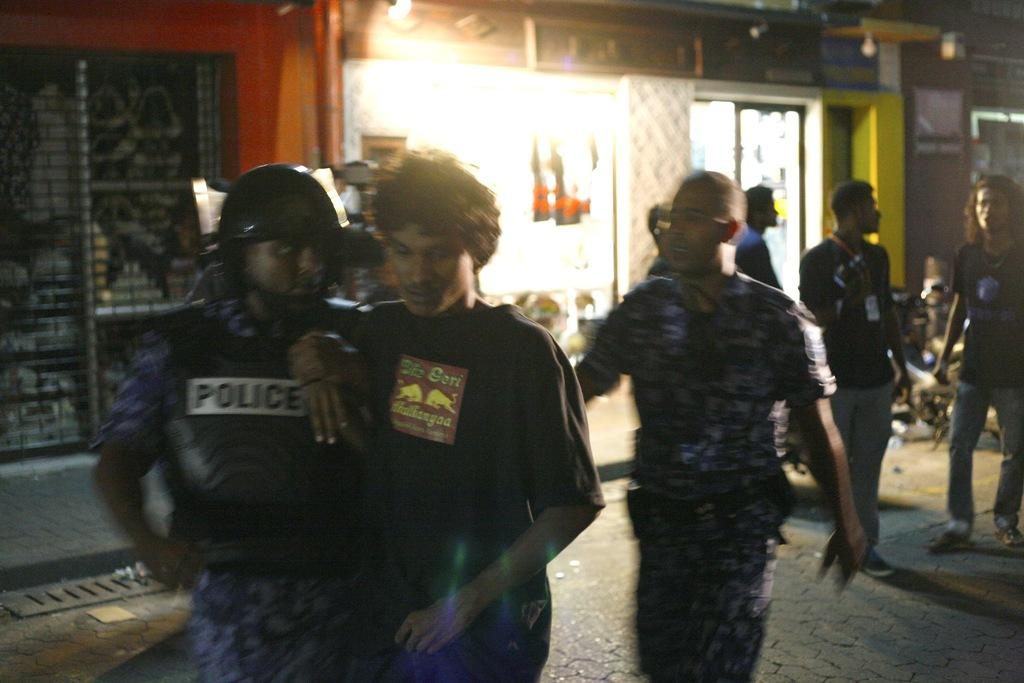How many people are in the image? There are people in the image, but the exact number is not specified. What are some of the people doing in the image? Some people are standing, and some are walking in the image. Where does the scene take place? The scene takes place in a street. What can be seen in the background of the image? There is a building in the background of the image. What type of vehicle is present in the image? There is a motorcycle in the image. What is the purpose of the pleasure in the image? There is no mention of pleasure in the image, so it is not possible to determine its purpose. 